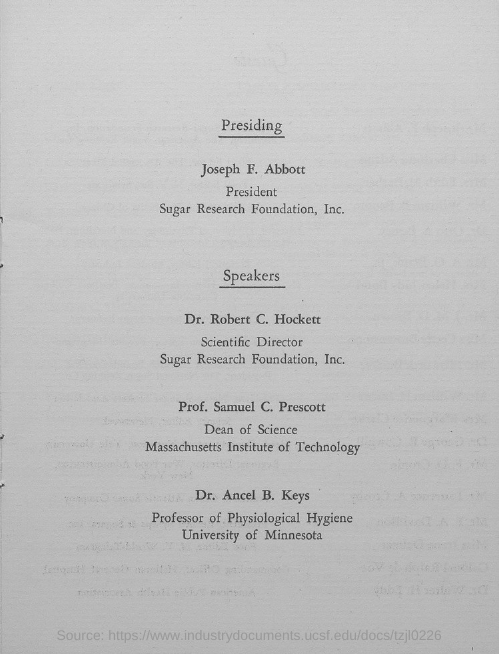Who is the president of Sugar Research  Foundation, Inc.?
Ensure brevity in your answer.  Joseph F. Abbott. What is the designation of Dr. Robert C. Hockett?
Ensure brevity in your answer.  Scientific director. What is the designation of Prof. Samuel C. Prescott?
Give a very brief answer. Speaker. In which university, Dr. Ancel B. Keys works?
Ensure brevity in your answer.  University of minnesota. 